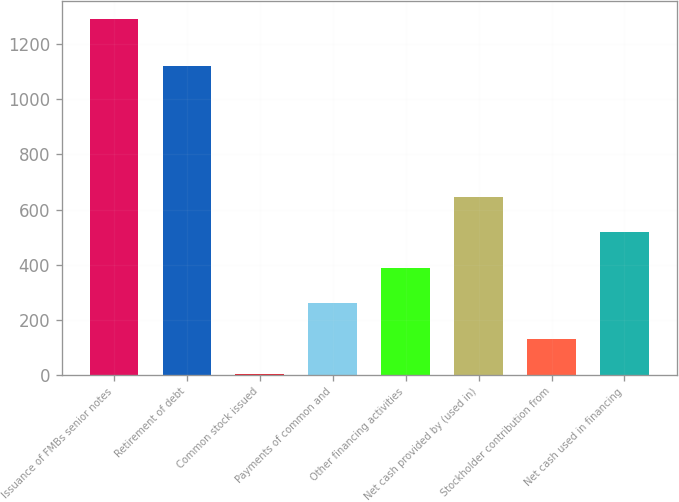Convert chart to OTSL. <chart><loc_0><loc_0><loc_500><loc_500><bar_chart><fcel>Issuance of FMBs senior notes<fcel>Retirement of debt<fcel>Common stock issued<fcel>Payments of common and<fcel>Other financing activities<fcel>Net cash provided by (used in)<fcel>Stockholder contribution from<fcel>Net cash used in financing<nl><fcel>1292<fcel>1121<fcel>1<fcel>259.2<fcel>388.3<fcel>646.5<fcel>130.1<fcel>517.4<nl></chart> 